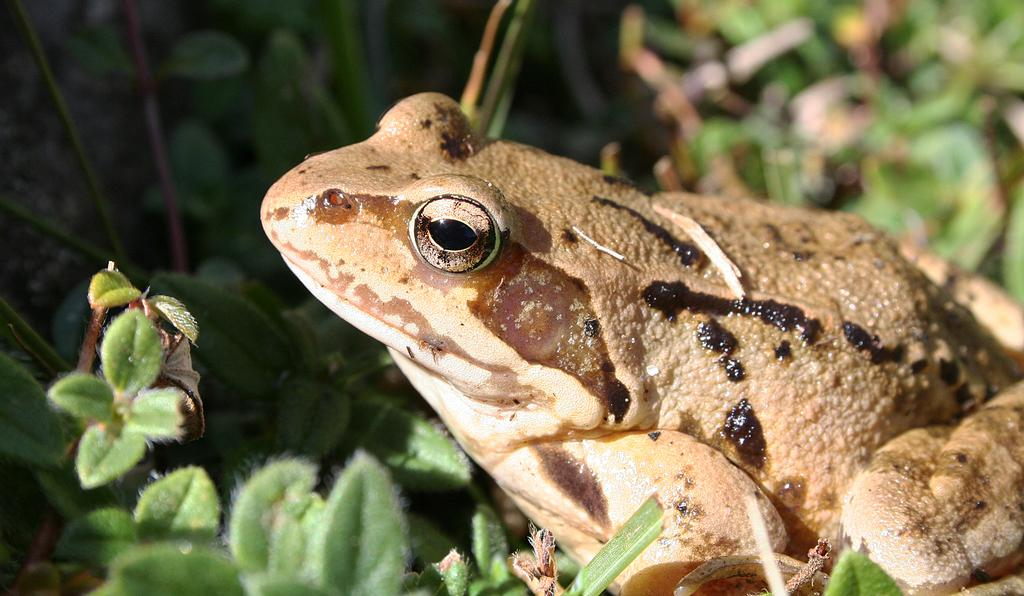What animal is present in the picture? There is a frog in the picture. Where is the frog located in relation to other objects in the image? The frog is sitting near plants. What can be seen at the bottom of the image? Leaves are visible at the bottom of the image. What type of pencil is the frog using to draw in the image? There is no pencil present in the image, and the frog is not drawing. 